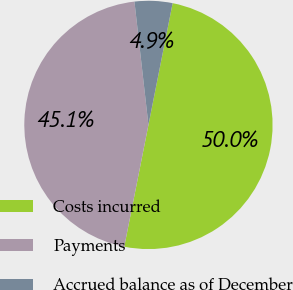Convert chart. <chart><loc_0><loc_0><loc_500><loc_500><pie_chart><fcel>Costs incurred<fcel>Payments<fcel>Accrued balance as of December<nl><fcel>50.0%<fcel>45.08%<fcel>4.92%<nl></chart> 